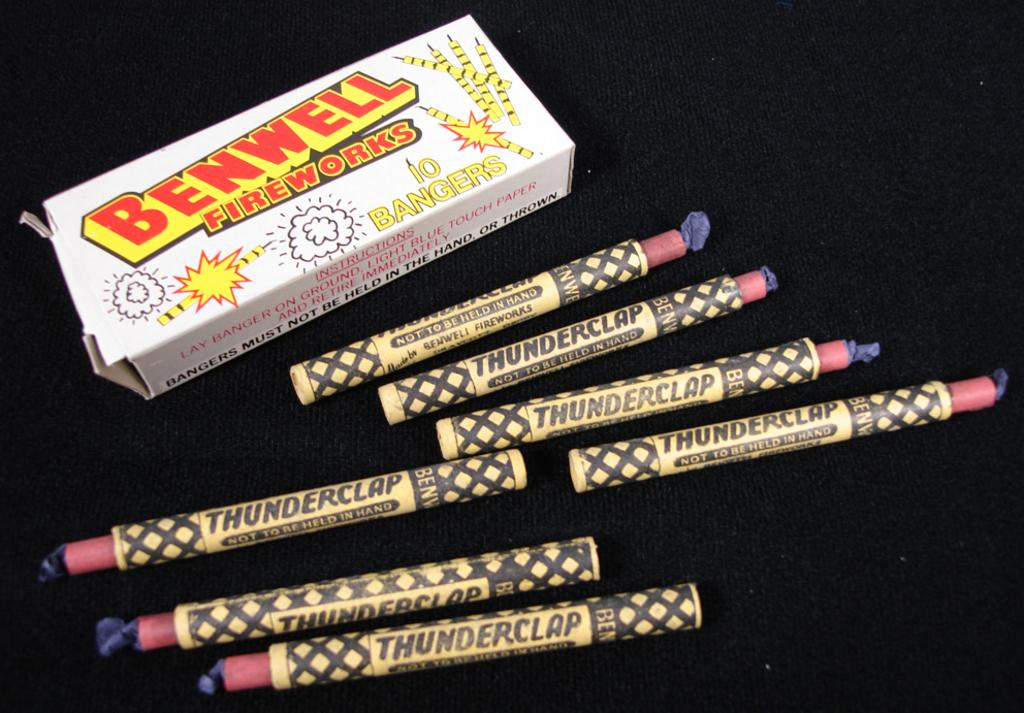<image>
Provide a brief description of the given image. A pack of 7 Thunderclaps from Benwell Fireworks 